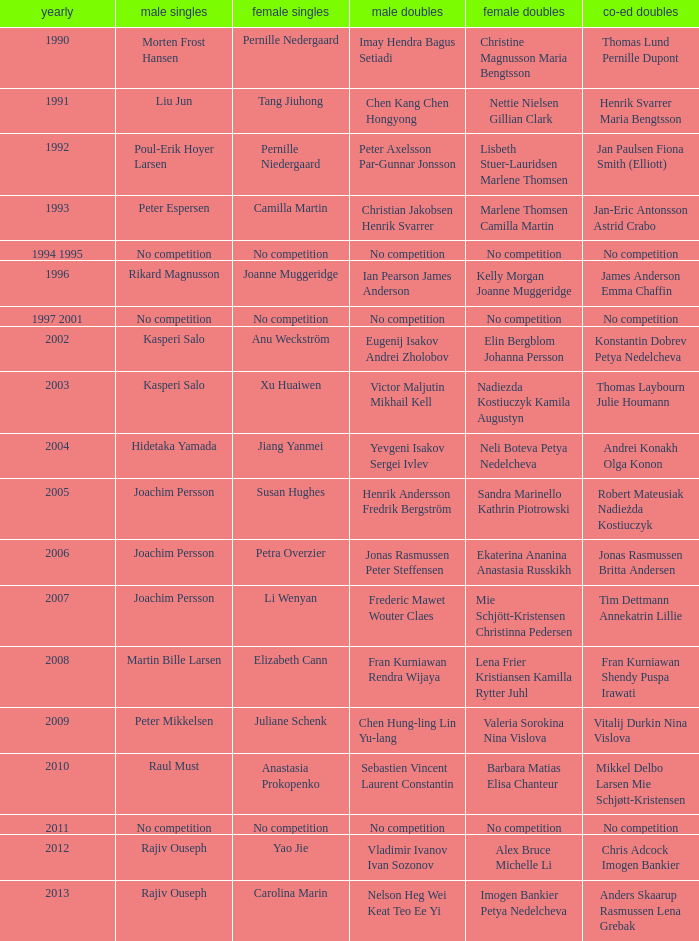Who won the Mixed Doubles in 2007? Tim Dettmann Annekatrin Lillie. 